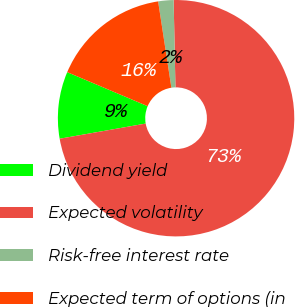Convert chart to OTSL. <chart><loc_0><loc_0><loc_500><loc_500><pie_chart><fcel>Dividend yield<fcel>Expected volatility<fcel>Risk-free interest rate<fcel>Expected term of options (in<nl><fcel>9.15%<fcel>72.55%<fcel>2.1%<fcel>16.2%<nl></chart> 